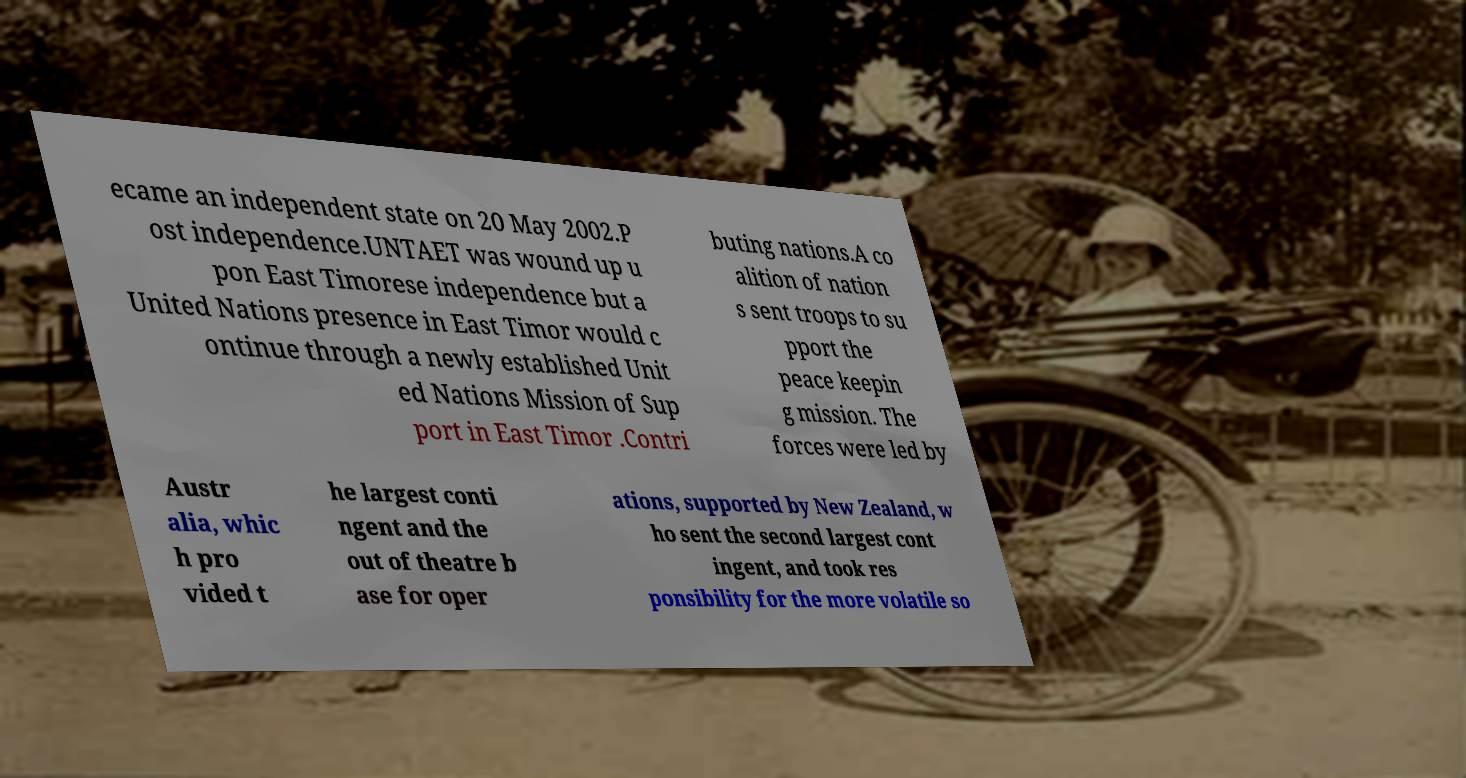What messages or text are displayed in this image? I need them in a readable, typed format. ecame an independent state on 20 May 2002.P ost independence.UNTAET was wound up u pon East Timorese independence but a United Nations presence in East Timor would c ontinue through a newly established Unit ed Nations Mission of Sup port in East Timor .Contri buting nations.A co alition of nation s sent troops to su pport the peace keepin g mission. The forces were led by Austr alia, whic h pro vided t he largest conti ngent and the out of theatre b ase for oper ations, supported by New Zealand, w ho sent the second largest cont ingent, and took res ponsibility for the more volatile so 